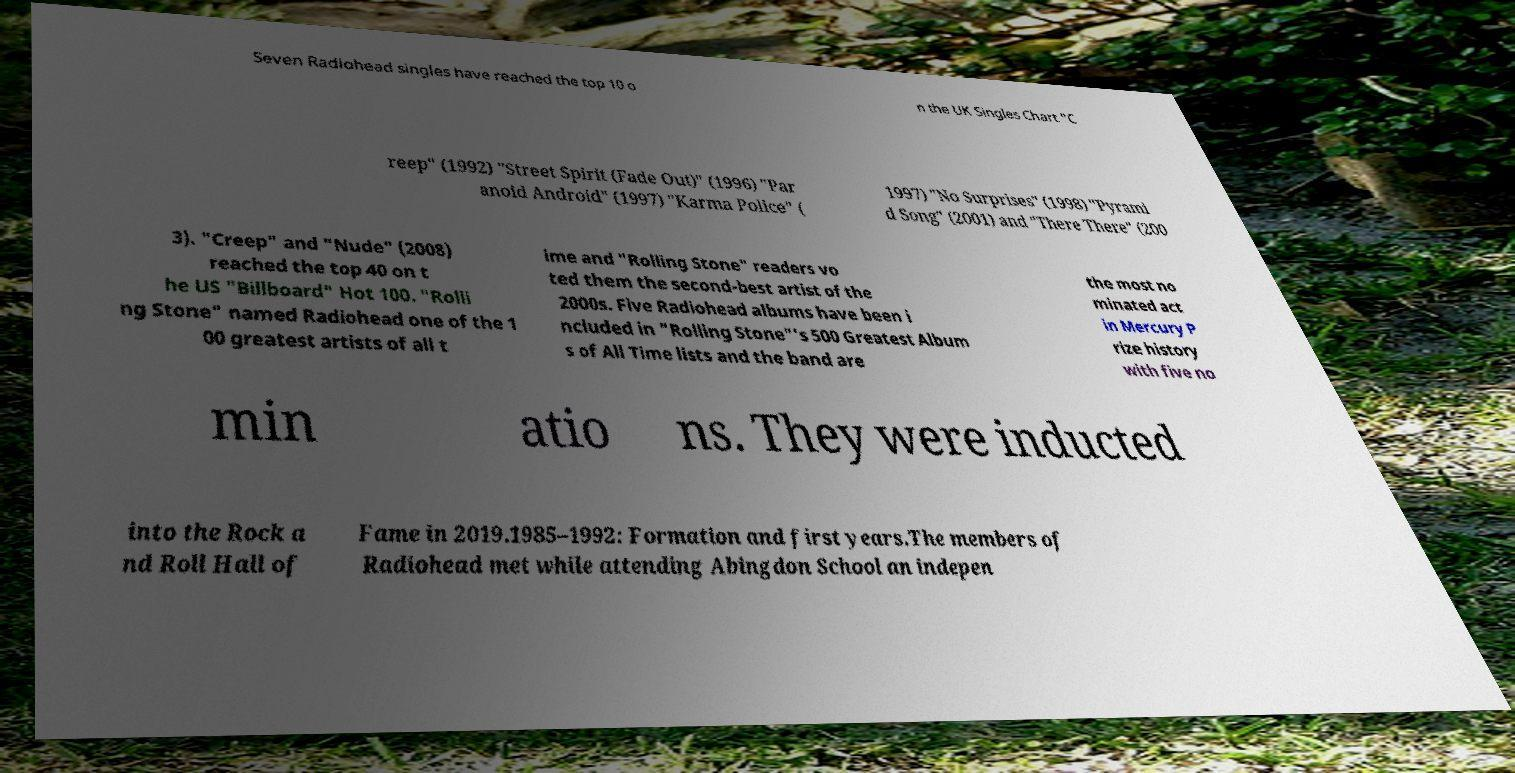For documentation purposes, I need the text within this image transcribed. Could you provide that? Seven Radiohead singles have reached the top 10 o n the UK Singles Chart "C reep" (1992) "Street Spirit (Fade Out)" (1996) "Par anoid Android" (1997) "Karma Police" ( 1997) "No Surprises" (1998) "Pyrami d Song" (2001) and "There There" (200 3). "Creep" and "Nude" (2008) reached the top 40 on t he US "Billboard" Hot 100. "Rolli ng Stone" named Radiohead one of the 1 00 greatest artists of all t ime and "Rolling Stone" readers vo ted them the second-best artist of the 2000s. Five Radiohead albums have been i ncluded in "Rolling Stone"'s 500 Greatest Album s of All Time lists and the band are the most no minated act in Mercury P rize history with five no min atio ns. They were inducted into the Rock a nd Roll Hall of Fame in 2019.1985–1992: Formation and first years.The members of Radiohead met while attending Abingdon School an indepen 